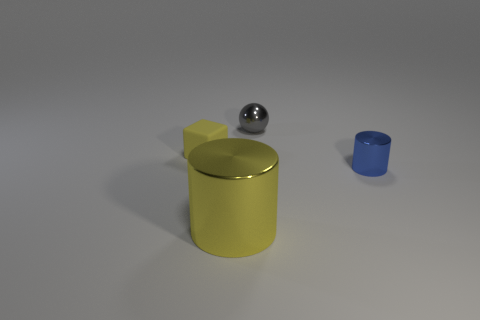Add 2 small metallic things. How many objects exist? 6 Subtract all blocks. How many objects are left? 3 Add 2 tiny metallic things. How many tiny metallic things are left? 4 Add 4 brown shiny objects. How many brown shiny objects exist? 4 Subtract 0 cyan cylinders. How many objects are left? 4 Subtract all small red cubes. Subtract all rubber cubes. How many objects are left? 3 